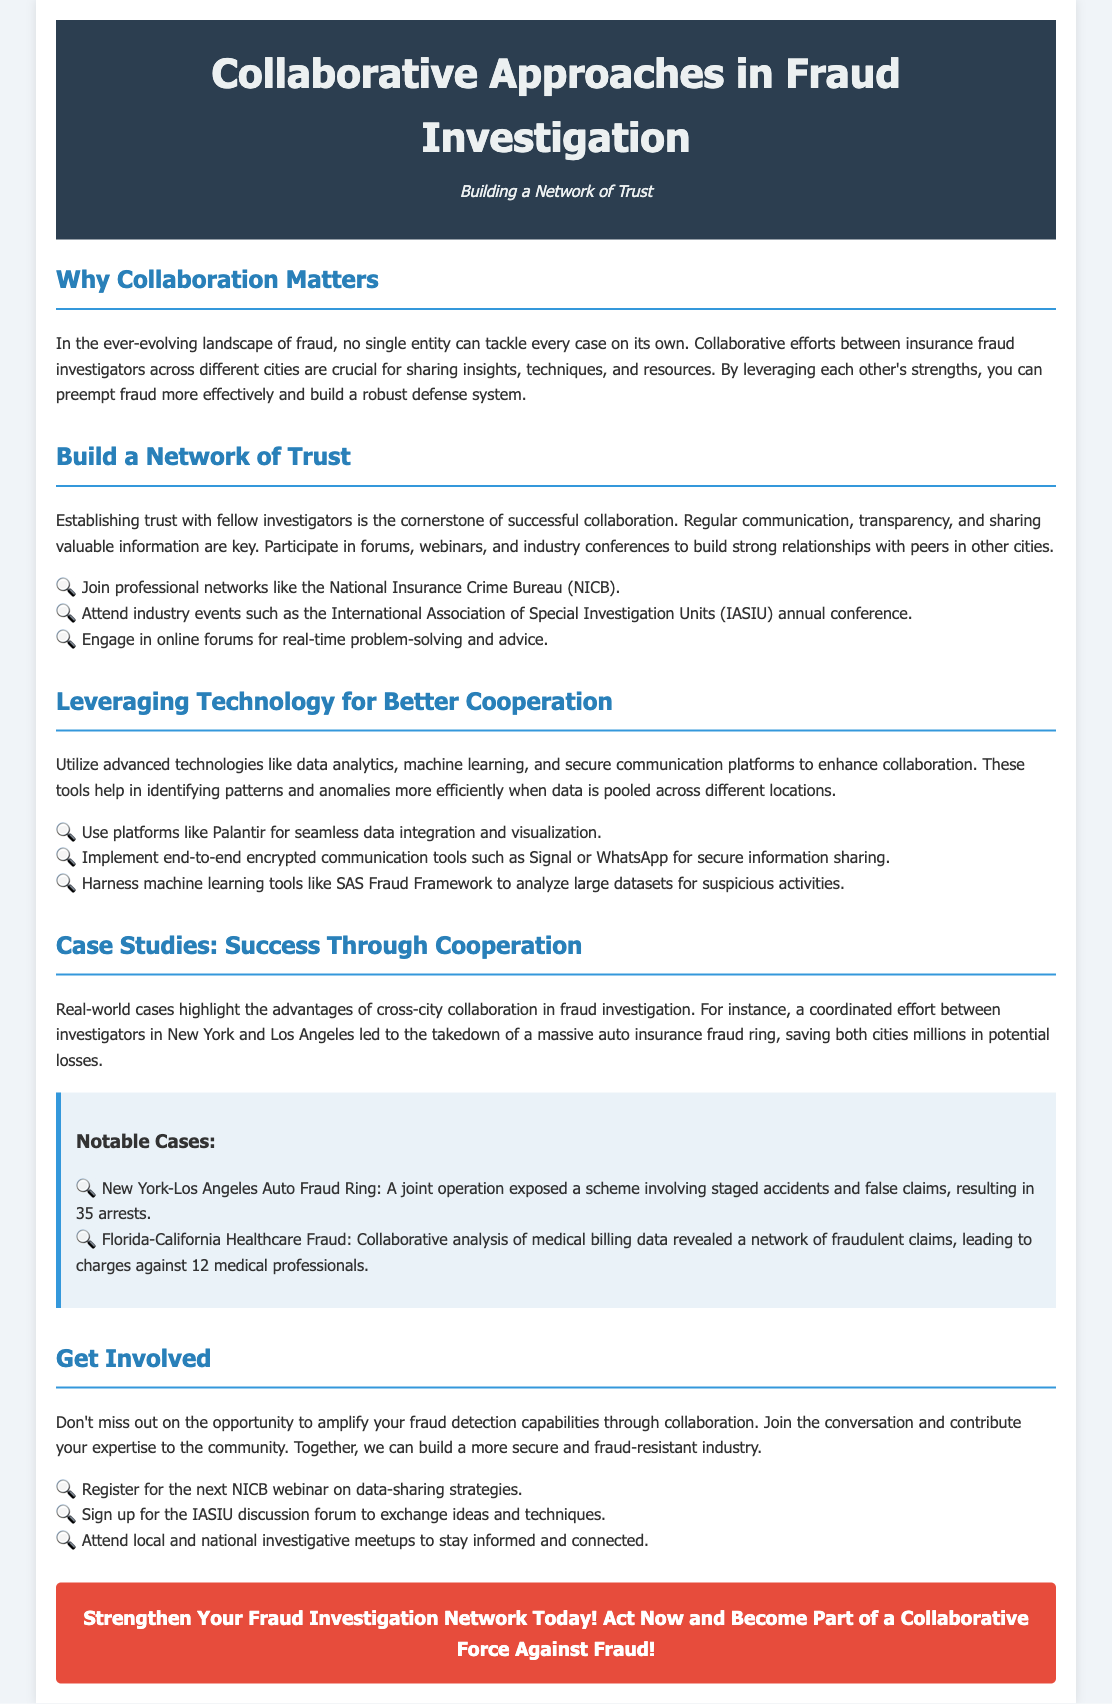What is the primary focus of the document? The document discusses collaborative approaches in fraud investigation, emphasizing teamwork and cross-city cooperation.
Answer: Collaborative Approaches in Fraud Investigation What is one key aspect of building a network of trust? According to the document, one key aspect is regular communication and transparency among investigators.
Answer: Regular communication Which professional network is mentioned for collaboration? The National Insurance Crime Bureau is highlighted as a professional network to join.
Answer: National Insurance Crime Bureau How many arrests were made in the New York-Los Angeles auto fraud ring case? The document specifies that there were 35 arrests in this case of collaborative fraud investigation.
Answer: 35 What tool is suggested for secure information sharing? The text recommends using end-to-end encrypted communication tools, such as Signal or WhatsApp.
Answer: Signal or WhatsApp What was a notable result of cross-city collaboration in fraud investigations? The case studies illustrate that such collaborations led to significant arrests and savings, including millions saved in potential losses from fraud.
Answer: Millions saved What are participants encouraged to do to strengthen their fraud detection capabilities? The document encourages individuals to join discussions and contribute their expertise to the community.
Answer: Join discussions How many medical professionals were charged in the Florida-California healthcare fraud case? The document states that charges were brought against 12 medical professionals involved in the fraudulent claims network.
Answer: 12 What is the call to action at the end of the document? The conclusion encourages readers to become part of a collaborative force against fraud by strengthening their networks.
Answer: Strengthen Your Fraud Investigation Network Today! 